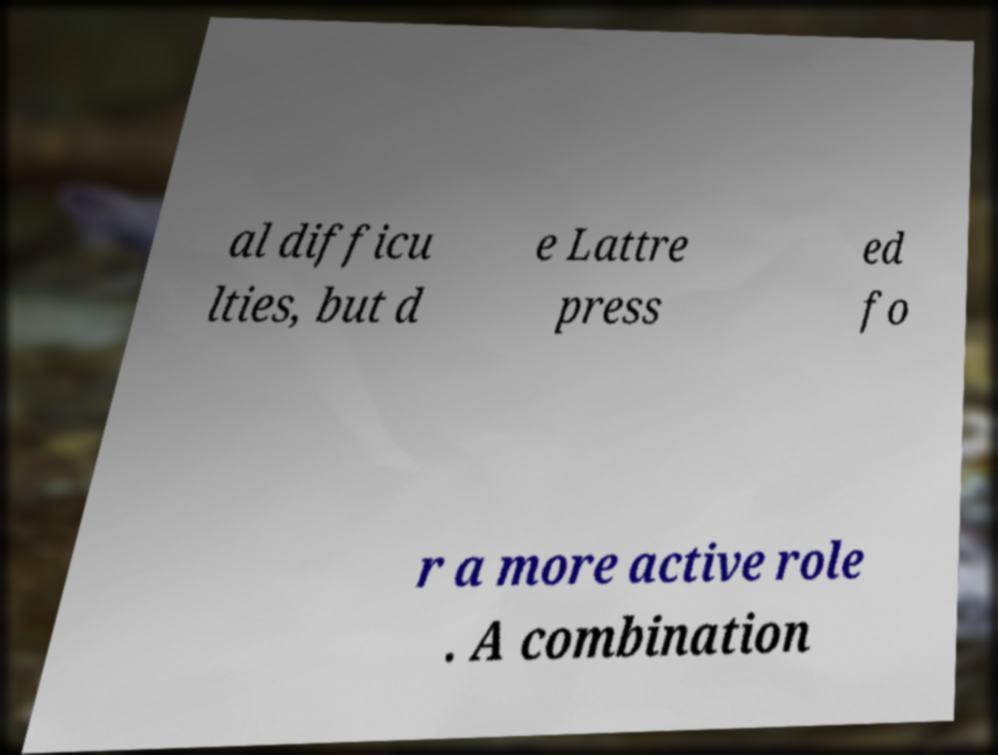Can you read and provide the text displayed in the image?This photo seems to have some interesting text. Can you extract and type it out for me? al difficu lties, but d e Lattre press ed fo r a more active role . A combination 